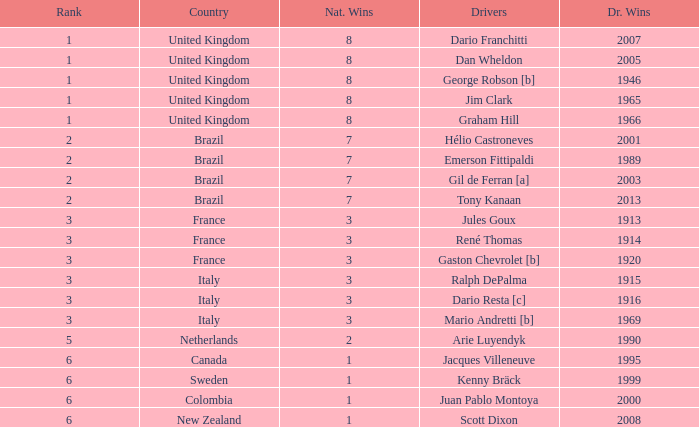What is the average number of wins of drivers from Sweden? 1999.0. 